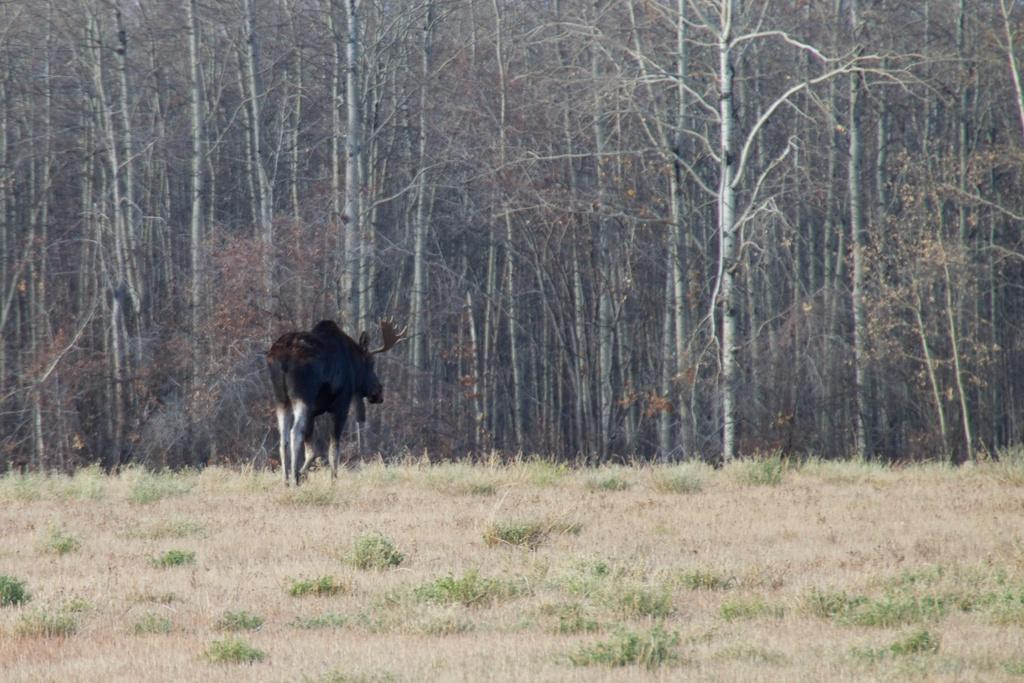What animal is present in the image? There is a black-buck in the image. What is the black-buck doing in the image? The black-buck is standing on the ground. What type of vegetation can be seen at the bottom of the image? Grass is visible at the bottom of the image. What can be seen in the background of the image? There are trees in the background of the image. What type of chair is the black-buck sitting on in the image? There is no chair present in the image; the black-buck is standing on the ground. 